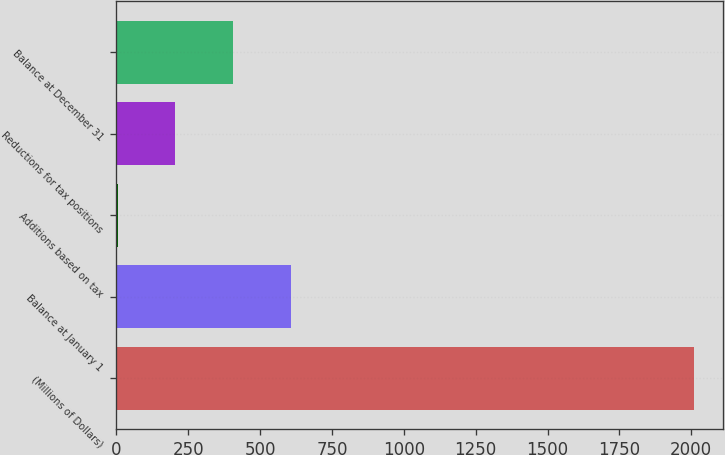<chart> <loc_0><loc_0><loc_500><loc_500><bar_chart><fcel>(Millions of Dollars)<fcel>Balance at January 1<fcel>Additions based on tax<fcel>Reductions for tax positions<fcel>Balance at December 31<nl><fcel>2010<fcel>605.8<fcel>4<fcel>204.6<fcel>405.2<nl></chart> 